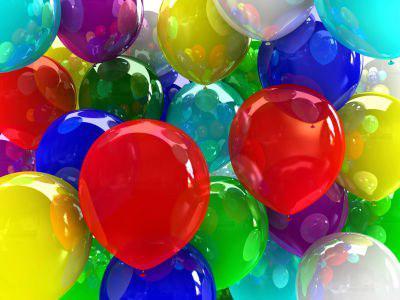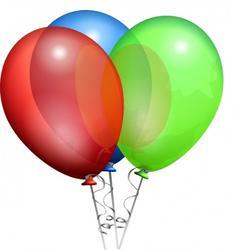The first image is the image on the left, the second image is the image on the right. For the images displayed, is the sentence "The right image has three balloons all facing upwards." factually correct? Answer yes or no. Yes. 